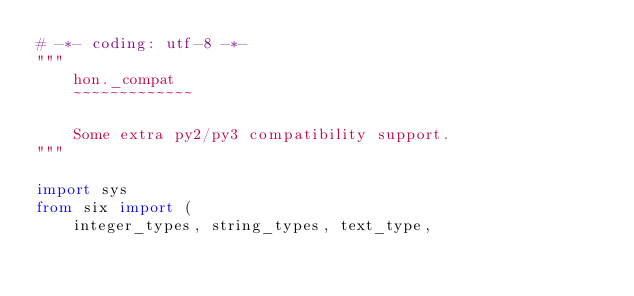<code> <loc_0><loc_0><loc_500><loc_500><_Python_># -*- coding: utf-8 -*-
"""
    hon._compat
    ~~~~~~~~~~~~~

    Some extra py2/py3 compatibility support.
"""

import sys
from six import (
    integer_types, string_types, text_type,</code> 